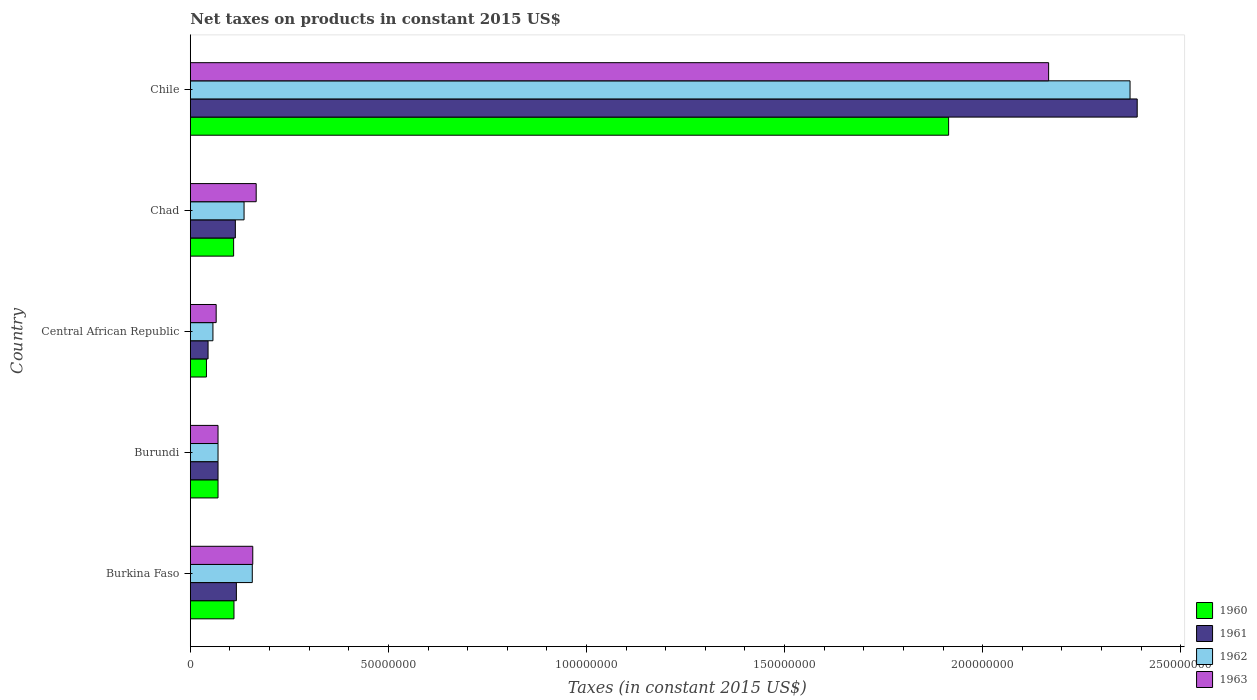How many groups of bars are there?
Offer a terse response. 5. Are the number of bars per tick equal to the number of legend labels?
Make the answer very short. Yes. How many bars are there on the 4th tick from the top?
Offer a terse response. 4. How many bars are there on the 3rd tick from the bottom?
Your answer should be compact. 4. In how many cases, is the number of bars for a given country not equal to the number of legend labels?
Provide a short and direct response. 0. What is the net taxes on products in 1963 in Chad?
Give a very brief answer. 1.66e+07. Across all countries, what is the maximum net taxes on products in 1962?
Your response must be concise. 2.37e+08. Across all countries, what is the minimum net taxes on products in 1960?
Provide a succinct answer. 4.08e+06. In which country was the net taxes on products in 1960 maximum?
Give a very brief answer. Chile. In which country was the net taxes on products in 1963 minimum?
Give a very brief answer. Central African Republic. What is the total net taxes on products in 1962 in the graph?
Make the answer very short. 2.79e+08. What is the difference between the net taxes on products in 1962 in Burundi and that in Central African Republic?
Your answer should be compact. 1.29e+06. What is the difference between the net taxes on products in 1963 in Burkina Faso and the net taxes on products in 1960 in Central African Republic?
Ensure brevity in your answer.  1.17e+07. What is the average net taxes on products in 1962 per country?
Provide a succinct answer. 5.58e+07. What is the ratio of the net taxes on products in 1961 in Central African Republic to that in Chad?
Your response must be concise. 0.39. Is the net taxes on products in 1960 in Chad less than that in Chile?
Keep it short and to the point. Yes. What is the difference between the highest and the second highest net taxes on products in 1963?
Offer a very short reply. 2.00e+08. What is the difference between the highest and the lowest net taxes on products in 1962?
Your answer should be very brief. 2.31e+08. In how many countries, is the net taxes on products in 1960 greater than the average net taxes on products in 1960 taken over all countries?
Your answer should be compact. 1. Is it the case that in every country, the sum of the net taxes on products in 1960 and net taxes on products in 1961 is greater than the sum of net taxes on products in 1962 and net taxes on products in 1963?
Your answer should be very brief. No. What does the 2nd bar from the top in Burkina Faso represents?
Make the answer very short. 1962. Are all the bars in the graph horizontal?
Keep it short and to the point. Yes. Does the graph contain any zero values?
Offer a very short reply. No. Where does the legend appear in the graph?
Give a very brief answer. Bottom right. What is the title of the graph?
Ensure brevity in your answer.  Net taxes on products in constant 2015 US$. Does "2015" appear as one of the legend labels in the graph?
Your answer should be compact. No. What is the label or title of the X-axis?
Make the answer very short. Taxes (in constant 2015 US$). What is the label or title of the Y-axis?
Offer a very short reply. Country. What is the Taxes (in constant 2015 US$) in 1960 in Burkina Faso?
Give a very brief answer. 1.10e+07. What is the Taxes (in constant 2015 US$) of 1961 in Burkina Faso?
Your response must be concise. 1.16e+07. What is the Taxes (in constant 2015 US$) in 1962 in Burkina Faso?
Offer a very short reply. 1.56e+07. What is the Taxes (in constant 2015 US$) in 1963 in Burkina Faso?
Your answer should be very brief. 1.58e+07. What is the Taxes (in constant 2015 US$) of 1963 in Burundi?
Offer a terse response. 7.00e+06. What is the Taxes (in constant 2015 US$) of 1960 in Central African Republic?
Give a very brief answer. 4.08e+06. What is the Taxes (in constant 2015 US$) of 1961 in Central African Republic?
Your response must be concise. 4.49e+06. What is the Taxes (in constant 2015 US$) of 1962 in Central African Republic?
Your answer should be very brief. 5.71e+06. What is the Taxes (in constant 2015 US$) in 1963 in Central African Republic?
Offer a very short reply. 6.53e+06. What is the Taxes (in constant 2015 US$) of 1960 in Chad?
Keep it short and to the point. 1.09e+07. What is the Taxes (in constant 2015 US$) in 1961 in Chad?
Give a very brief answer. 1.14e+07. What is the Taxes (in constant 2015 US$) of 1962 in Chad?
Offer a very short reply. 1.36e+07. What is the Taxes (in constant 2015 US$) of 1963 in Chad?
Offer a very short reply. 1.66e+07. What is the Taxes (in constant 2015 US$) of 1960 in Chile?
Give a very brief answer. 1.91e+08. What is the Taxes (in constant 2015 US$) in 1961 in Chile?
Provide a succinct answer. 2.39e+08. What is the Taxes (in constant 2015 US$) in 1962 in Chile?
Give a very brief answer. 2.37e+08. What is the Taxes (in constant 2015 US$) in 1963 in Chile?
Provide a short and direct response. 2.17e+08. Across all countries, what is the maximum Taxes (in constant 2015 US$) of 1960?
Your answer should be compact. 1.91e+08. Across all countries, what is the maximum Taxes (in constant 2015 US$) in 1961?
Ensure brevity in your answer.  2.39e+08. Across all countries, what is the maximum Taxes (in constant 2015 US$) in 1962?
Offer a terse response. 2.37e+08. Across all countries, what is the maximum Taxes (in constant 2015 US$) in 1963?
Offer a very short reply. 2.17e+08. Across all countries, what is the minimum Taxes (in constant 2015 US$) in 1960?
Your response must be concise. 4.08e+06. Across all countries, what is the minimum Taxes (in constant 2015 US$) in 1961?
Make the answer very short. 4.49e+06. Across all countries, what is the minimum Taxes (in constant 2015 US$) of 1962?
Offer a very short reply. 5.71e+06. Across all countries, what is the minimum Taxes (in constant 2015 US$) of 1963?
Offer a very short reply. 6.53e+06. What is the total Taxes (in constant 2015 US$) of 1960 in the graph?
Offer a very short reply. 2.24e+08. What is the total Taxes (in constant 2015 US$) in 1961 in the graph?
Offer a terse response. 2.73e+08. What is the total Taxes (in constant 2015 US$) of 1962 in the graph?
Give a very brief answer. 2.79e+08. What is the total Taxes (in constant 2015 US$) of 1963 in the graph?
Provide a short and direct response. 2.63e+08. What is the difference between the Taxes (in constant 2015 US$) in 1960 in Burkina Faso and that in Burundi?
Make the answer very short. 4.02e+06. What is the difference between the Taxes (in constant 2015 US$) in 1961 in Burkina Faso and that in Burundi?
Your answer should be compact. 4.63e+06. What is the difference between the Taxes (in constant 2015 US$) in 1962 in Burkina Faso and that in Burundi?
Your answer should be very brief. 8.65e+06. What is the difference between the Taxes (in constant 2015 US$) of 1963 in Burkina Faso and that in Burundi?
Your answer should be compact. 8.77e+06. What is the difference between the Taxes (in constant 2015 US$) of 1960 in Burkina Faso and that in Central African Republic?
Ensure brevity in your answer.  6.94e+06. What is the difference between the Taxes (in constant 2015 US$) of 1961 in Burkina Faso and that in Central African Republic?
Make the answer very short. 7.15e+06. What is the difference between the Taxes (in constant 2015 US$) in 1962 in Burkina Faso and that in Central African Republic?
Provide a short and direct response. 9.93e+06. What is the difference between the Taxes (in constant 2015 US$) of 1963 in Burkina Faso and that in Central African Republic?
Offer a very short reply. 9.24e+06. What is the difference between the Taxes (in constant 2015 US$) in 1960 in Burkina Faso and that in Chad?
Your answer should be very brief. 8.71e+04. What is the difference between the Taxes (in constant 2015 US$) in 1961 in Burkina Faso and that in Chad?
Give a very brief answer. 2.61e+05. What is the difference between the Taxes (in constant 2015 US$) in 1962 in Burkina Faso and that in Chad?
Your answer should be very brief. 2.08e+06. What is the difference between the Taxes (in constant 2015 US$) of 1963 in Burkina Faso and that in Chad?
Offer a very short reply. -8.65e+05. What is the difference between the Taxes (in constant 2015 US$) in 1960 in Burkina Faso and that in Chile?
Offer a very short reply. -1.80e+08. What is the difference between the Taxes (in constant 2015 US$) in 1961 in Burkina Faso and that in Chile?
Offer a terse response. -2.27e+08. What is the difference between the Taxes (in constant 2015 US$) of 1962 in Burkina Faso and that in Chile?
Ensure brevity in your answer.  -2.22e+08. What is the difference between the Taxes (in constant 2015 US$) of 1963 in Burkina Faso and that in Chile?
Your answer should be compact. -2.01e+08. What is the difference between the Taxes (in constant 2015 US$) in 1960 in Burundi and that in Central African Republic?
Offer a terse response. 2.92e+06. What is the difference between the Taxes (in constant 2015 US$) in 1961 in Burundi and that in Central African Republic?
Your answer should be very brief. 2.51e+06. What is the difference between the Taxes (in constant 2015 US$) in 1962 in Burundi and that in Central African Republic?
Offer a very short reply. 1.29e+06. What is the difference between the Taxes (in constant 2015 US$) in 1963 in Burundi and that in Central African Republic?
Your answer should be very brief. 4.70e+05. What is the difference between the Taxes (in constant 2015 US$) of 1960 in Burundi and that in Chad?
Your answer should be compact. -3.94e+06. What is the difference between the Taxes (in constant 2015 US$) in 1961 in Burundi and that in Chad?
Your answer should be compact. -4.37e+06. What is the difference between the Taxes (in constant 2015 US$) in 1962 in Burundi and that in Chad?
Your answer should be very brief. -6.57e+06. What is the difference between the Taxes (in constant 2015 US$) in 1963 in Burundi and that in Chad?
Offer a very short reply. -9.63e+06. What is the difference between the Taxes (in constant 2015 US$) in 1960 in Burundi and that in Chile?
Your answer should be compact. -1.84e+08. What is the difference between the Taxes (in constant 2015 US$) of 1961 in Burundi and that in Chile?
Provide a succinct answer. -2.32e+08. What is the difference between the Taxes (in constant 2015 US$) of 1962 in Burundi and that in Chile?
Give a very brief answer. -2.30e+08. What is the difference between the Taxes (in constant 2015 US$) of 1963 in Burundi and that in Chile?
Your response must be concise. -2.10e+08. What is the difference between the Taxes (in constant 2015 US$) of 1960 in Central African Republic and that in Chad?
Make the answer very short. -6.86e+06. What is the difference between the Taxes (in constant 2015 US$) of 1961 in Central African Republic and that in Chad?
Keep it short and to the point. -6.88e+06. What is the difference between the Taxes (in constant 2015 US$) of 1962 in Central African Republic and that in Chad?
Keep it short and to the point. -7.86e+06. What is the difference between the Taxes (in constant 2015 US$) of 1963 in Central African Republic and that in Chad?
Make the answer very short. -1.01e+07. What is the difference between the Taxes (in constant 2015 US$) of 1960 in Central African Republic and that in Chile?
Your response must be concise. -1.87e+08. What is the difference between the Taxes (in constant 2015 US$) in 1961 in Central African Republic and that in Chile?
Provide a short and direct response. -2.35e+08. What is the difference between the Taxes (in constant 2015 US$) in 1962 in Central African Republic and that in Chile?
Give a very brief answer. -2.31e+08. What is the difference between the Taxes (in constant 2015 US$) of 1963 in Central African Republic and that in Chile?
Offer a terse response. -2.10e+08. What is the difference between the Taxes (in constant 2015 US$) in 1960 in Chad and that in Chile?
Provide a short and direct response. -1.80e+08. What is the difference between the Taxes (in constant 2015 US$) of 1961 in Chad and that in Chile?
Your answer should be very brief. -2.28e+08. What is the difference between the Taxes (in constant 2015 US$) in 1962 in Chad and that in Chile?
Give a very brief answer. -2.24e+08. What is the difference between the Taxes (in constant 2015 US$) in 1963 in Chad and that in Chile?
Keep it short and to the point. -2.00e+08. What is the difference between the Taxes (in constant 2015 US$) of 1960 in Burkina Faso and the Taxes (in constant 2015 US$) of 1961 in Burundi?
Give a very brief answer. 4.02e+06. What is the difference between the Taxes (in constant 2015 US$) of 1960 in Burkina Faso and the Taxes (in constant 2015 US$) of 1962 in Burundi?
Your answer should be very brief. 4.02e+06. What is the difference between the Taxes (in constant 2015 US$) in 1960 in Burkina Faso and the Taxes (in constant 2015 US$) in 1963 in Burundi?
Your answer should be compact. 4.02e+06. What is the difference between the Taxes (in constant 2015 US$) of 1961 in Burkina Faso and the Taxes (in constant 2015 US$) of 1962 in Burundi?
Ensure brevity in your answer.  4.63e+06. What is the difference between the Taxes (in constant 2015 US$) of 1961 in Burkina Faso and the Taxes (in constant 2015 US$) of 1963 in Burundi?
Give a very brief answer. 4.63e+06. What is the difference between the Taxes (in constant 2015 US$) in 1962 in Burkina Faso and the Taxes (in constant 2015 US$) in 1963 in Burundi?
Keep it short and to the point. 8.65e+06. What is the difference between the Taxes (in constant 2015 US$) in 1960 in Burkina Faso and the Taxes (in constant 2015 US$) in 1961 in Central African Republic?
Make the answer very short. 6.54e+06. What is the difference between the Taxes (in constant 2015 US$) in 1960 in Burkina Faso and the Taxes (in constant 2015 US$) in 1962 in Central African Republic?
Keep it short and to the point. 5.31e+06. What is the difference between the Taxes (in constant 2015 US$) of 1960 in Burkina Faso and the Taxes (in constant 2015 US$) of 1963 in Central African Republic?
Give a very brief answer. 4.49e+06. What is the difference between the Taxes (in constant 2015 US$) of 1961 in Burkina Faso and the Taxes (in constant 2015 US$) of 1962 in Central African Republic?
Your answer should be compact. 5.92e+06. What is the difference between the Taxes (in constant 2015 US$) of 1961 in Burkina Faso and the Taxes (in constant 2015 US$) of 1963 in Central African Republic?
Your answer should be compact. 5.10e+06. What is the difference between the Taxes (in constant 2015 US$) of 1962 in Burkina Faso and the Taxes (in constant 2015 US$) of 1963 in Central African Republic?
Ensure brevity in your answer.  9.12e+06. What is the difference between the Taxes (in constant 2015 US$) in 1960 in Burkina Faso and the Taxes (in constant 2015 US$) in 1961 in Chad?
Keep it short and to the point. -3.47e+05. What is the difference between the Taxes (in constant 2015 US$) of 1960 in Burkina Faso and the Taxes (in constant 2015 US$) of 1962 in Chad?
Make the answer very short. -2.55e+06. What is the difference between the Taxes (in constant 2015 US$) in 1960 in Burkina Faso and the Taxes (in constant 2015 US$) in 1963 in Chad?
Your response must be concise. -5.61e+06. What is the difference between the Taxes (in constant 2015 US$) in 1961 in Burkina Faso and the Taxes (in constant 2015 US$) in 1962 in Chad?
Offer a terse response. -1.94e+06. What is the difference between the Taxes (in constant 2015 US$) in 1961 in Burkina Faso and the Taxes (in constant 2015 US$) in 1963 in Chad?
Offer a terse response. -5.00e+06. What is the difference between the Taxes (in constant 2015 US$) in 1962 in Burkina Faso and the Taxes (in constant 2015 US$) in 1963 in Chad?
Provide a succinct answer. -9.87e+05. What is the difference between the Taxes (in constant 2015 US$) of 1960 in Burkina Faso and the Taxes (in constant 2015 US$) of 1961 in Chile?
Offer a very short reply. -2.28e+08. What is the difference between the Taxes (in constant 2015 US$) in 1960 in Burkina Faso and the Taxes (in constant 2015 US$) in 1962 in Chile?
Offer a very short reply. -2.26e+08. What is the difference between the Taxes (in constant 2015 US$) in 1960 in Burkina Faso and the Taxes (in constant 2015 US$) in 1963 in Chile?
Provide a succinct answer. -2.06e+08. What is the difference between the Taxes (in constant 2015 US$) in 1961 in Burkina Faso and the Taxes (in constant 2015 US$) in 1962 in Chile?
Provide a succinct answer. -2.26e+08. What is the difference between the Taxes (in constant 2015 US$) in 1961 in Burkina Faso and the Taxes (in constant 2015 US$) in 1963 in Chile?
Provide a succinct answer. -2.05e+08. What is the difference between the Taxes (in constant 2015 US$) in 1962 in Burkina Faso and the Taxes (in constant 2015 US$) in 1963 in Chile?
Offer a terse response. -2.01e+08. What is the difference between the Taxes (in constant 2015 US$) in 1960 in Burundi and the Taxes (in constant 2015 US$) in 1961 in Central African Republic?
Offer a terse response. 2.51e+06. What is the difference between the Taxes (in constant 2015 US$) of 1960 in Burundi and the Taxes (in constant 2015 US$) of 1962 in Central African Republic?
Ensure brevity in your answer.  1.29e+06. What is the difference between the Taxes (in constant 2015 US$) of 1960 in Burundi and the Taxes (in constant 2015 US$) of 1963 in Central African Republic?
Your answer should be compact. 4.70e+05. What is the difference between the Taxes (in constant 2015 US$) of 1961 in Burundi and the Taxes (in constant 2015 US$) of 1962 in Central African Republic?
Ensure brevity in your answer.  1.29e+06. What is the difference between the Taxes (in constant 2015 US$) of 1961 in Burundi and the Taxes (in constant 2015 US$) of 1963 in Central African Republic?
Your answer should be compact. 4.70e+05. What is the difference between the Taxes (in constant 2015 US$) of 1962 in Burundi and the Taxes (in constant 2015 US$) of 1963 in Central African Republic?
Your response must be concise. 4.70e+05. What is the difference between the Taxes (in constant 2015 US$) of 1960 in Burundi and the Taxes (in constant 2015 US$) of 1961 in Chad?
Your answer should be very brief. -4.37e+06. What is the difference between the Taxes (in constant 2015 US$) in 1960 in Burundi and the Taxes (in constant 2015 US$) in 1962 in Chad?
Your answer should be very brief. -6.57e+06. What is the difference between the Taxes (in constant 2015 US$) in 1960 in Burundi and the Taxes (in constant 2015 US$) in 1963 in Chad?
Offer a very short reply. -9.63e+06. What is the difference between the Taxes (in constant 2015 US$) in 1961 in Burundi and the Taxes (in constant 2015 US$) in 1962 in Chad?
Your answer should be very brief. -6.57e+06. What is the difference between the Taxes (in constant 2015 US$) of 1961 in Burundi and the Taxes (in constant 2015 US$) of 1963 in Chad?
Your answer should be very brief. -9.63e+06. What is the difference between the Taxes (in constant 2015 US$) of 1962 in Burundi and the Taxes (in constant 2015 US$) of 1963 in Chad?
Offer a terse response. -9.63e+06. What is the difference between the Taxes (in constant 2015 US$) of 1960 in Burundi and the Taxes (in constant 2015 US$) of 1961 in Chile?
Keep it short and to the point. -2.32e+08. What is the difference between the Taxes (in constant 2015 US$) of 1960 in Burundi and the Taxes (in constant 2015 US$) of 1962 in Chile?
Your answer should be compact. -2.30e+08. What is the difference between the Taxes (in constant 2015 US$) of 1960 in Burundi and the Taxes (in constant 2015 US$) of 1963 in Chile?
Offer a terse response. -2.10e+08. What is the difference between the Taxes (in constant 2015 US$) of 1961 in Burundi and the Taxes (in constant 2015 US$) of 1962 in Chile?
Your response must be concise. -2.30e+08. What is the difference between the Taxes (in constant 2015 US$) of 1961 in Burundi and the Taxes (in constant 2015 US$) of 1963 in Chile?
Provide a short and direct response. -2.10e+08. What is the difference between the Taxes (in constant 2015 US$) in 1962 in Burundi and the Taxes (in constant 2015 US$) in 1963 in Chile?
Your answer should be very brief. -2.10e+08. What is the difference between the Taxes (in constant 2015 US$) in 1960 in Central African Republic and the Taxes (in constant 2015 US$) in 1961 in Chad?
Give a very brief answer. -7.29e+06. What is the difference between the Taxes (in constant 2015 US$) in 1960 in Central African Republic and the Taxes (in constant 2015 US$) in 1962 in Chad?
Give a very brief answer. -9.49e+06. What is the difference between the Taxes (in constant 2015 US$) of 1960 in Central African Republic and the Taxes (in constant 2015 US$) of 1963 in Chad?
Ensure brevity in your answer.  -1.26e+07. What is the difference between the Taxes (in constant 2015 US$) of 1961 in Central African Republic and the Taxes (in constant 2015 US$) of 1962 in Chad?
Your answer should be very brief. -9.08e+06. What is the difference between the Taxes (in constant 2015 US$) of 1961 in Central African Republic and the Taxes (in constant 2015 US$) of 1963 in Chad?
Ensure brevity in your answer.  -1.21e+07. What is the difference between the Taxes (in constant 2015 US$) in 1962 in Central African Republic and the Taxes (in constant 2015 US$) in 1963 in Chad?
Provide a succinct answer. -1.09e+07. What is the difference between the Taxes (in constant 2015 US$) of 1960 in Central African Republic and the Taxes (in constant 2015 US$) of 1961 in Chile?
Your response must be concise. -2.35e+08. What is the difference between the Taxes (in constant 2015 US$) of 1960 in Central African Republic and the Taxes (in constant 2015 US$) of 1962 in Chile?
Keep it short and to the point. -2.33e+08. What is the difference between the Taxes (in constant 2015 US$) of 1960 in Central African Republic and the Taxes (in constant 2015 US$) of 1963 in Chile?
Provide a short and direct response. -2.13e+08. What is the difference between the Taxes (in constant 2015 US$) in 1961 in Central African Republic and the Taxes (in constant 2015 US$) in 1962 in Chile?
Your answer should be very brief. -2.33e+08. What is the difference between the Taxes (in constant 2015 US$) in 1961 in Central African Republic and the Taxes (in constant 2015 US$) in 1963 in Chile?
Provide a short and direct response. -2.12e+08. What is the difference between the Taxes (in constant 2015 US$) in 1962 in Central African Republic and the Taxes (in constant 2015 US$) in 1963 in Chile?
Your answer should be compact. -2.11e+08. What is the difference between the Taxes (in constant 2015 US$) of 1960 in Chad and the Taxes (in constant 2015 US$) of 1961 in Chile?
Make the answer very short. -2.28e+08. What is the difference between the Taxes (in constant 2015 US$) in 1960 in Chad and the Taxes (in constant 2015 US$) in 1962 in Chile?
Give a very brief answer. -2.26e+08. What is the difference between the Taxes (in constant 2015 US$) in 1960 in Chad and the Taxes (in constant 2015 US$) in 1963 in Chile?
Keep it short and to the point. -2.06e+08. What is the difference between the Taxes (in constant 2015 US$) of 1961 in Chad and the Taxes (in constant 2015 US$) of 1962 in Chile?
Offer a terse response. -2.26e+08. What is the difference between the Taxes (in constant 2015 US$) of 1961 in Chad and the Taxes (in constant 2015 US$) of 1963 in Chile?
Keep it short and to the point. -2.05e+08. What is the difference between the Taxes (in constant 2015 US$) of 1962 in Chad and the Taxes (in constant 2015 US$) of 1963 in Chile?
Provide a short and direct response. -2.03e+08. What is the average Taxes (in constant 2015 US$) in 1960 per country?
Make the answer very short. 4.49e+07. What is the average Taxes (in constant 2015 US$) of 1961 per country?
Offer a very short reply. 5.47e+07. What is the average Taxes (in constant 2015 US$) of 1962 per country?
Give a very brief answer. 5.58e+07. What is the average Taxes (in constant 2015 US$) in 1963 per country?
Your response must be concise. 5.25e+07. What is the difference between the Taxes (in constant 2015 US$) in 1960 and Taxes (in constant 2015 US$) in 1961 in Burkina Faso?
Keep it short and to the point. -6.08e+05. What is the difference between the Taxes (in constant 2015 US$) in 1960 and Taxes (in constant 2015 US$) in 1962 in Burkina Faso?
Your response must be concise. -4.62e+06. What is the difference between the Taxes (in constant 2015 US$) of 1960 and Taxes (in constant 2015 US$) of 1963 in Burkina Faso?
Make the answer very short. -4.75e+06. What is the difference between the Taxes (in constant 2015 US$) of 1961 and Taxes (in constant 2015 US$) of 1962 in Burkina Faso?
Keep it short and to the point. -4.02e+06. What is the difference between the Taxes (in constant 2015 US$) in 1961 and Taxes (in constant 2015 US$) in 1963 in Burkina Faso?
Make the answer very short. -4.14e+06. What is the difference between the Taxes (in constant 2015 US$) of 1962 and Taxes (in constant 2015 US$) of 1963 in Burkina Faso?
Your answer should be very brief. -1.22e+05. What is the difference between the Taxes (in constant 2015 US$) of 1960 and Taxes (in constant 2015 US$) of 1962 in Burundi?
Offer a terse response. 0. What is the difference between the Taxes (in constant 2015 US$) in 1961 and Taxes (in constant 2015 US$) in 1963 in Burundi?
Offer a very short reply. 0. What is the difference between the Taxes (in constant 2015 US$) in 1960 and Taxes (in constant 2015 US$) in 1961 in Central African Republic?
Offer a very short reply. -4.07e+05. What is the difference between the Taxes (in constant 2015 US$) in 1960 and Taxes (in constant 2015 US$) in 1962 in Central African Republic?
Keep it short and to the point. -1.64e+06. What is the difference between the Taxes (in constant 2015 US$) in 1960 and Taxes (in constant 2015 US$) in 1963 in Central African Republic?
Your answer should be compact. -2.45e+06. What is the difference between the Taxes (in constant 2015 US$) in 1961 and Taxes (in constant 2015 US$) in 1962 in Central African Republic?
Your answer should be compact. -1.23e+06. What is the difference between the Taxes (in constant 2015 US$) in 1961 and Taxes (in constant 2015 US$) in 1963 in Central African Republic?
Give a very brief answer. -2.05e+06. What is the difference between the Taxes (in constant 2015 US$) in 1962 and Taxes (in constant 2015 US$) in 1963 in Central African Republic?
Your answer should be compact. -8.16e+05. What is the difference between the Taxes (in constant 2015 US$) of 1960 and Taxes (in constant 2015 US$) of 1961 in Chad?
Give a very brief answer. -4.34e+05. What is the difference between the Taxes (in constant 2015 US$) of 1960 and Taxes (in constant 2015 US$) of 1962 in Chad?
Offer a terse response. -2.63e+06. What is the difference between the Taxes (in constant 2015 US$) of 1960 and Taxes (in constant 2015 US$) of 1963 in Chad?
Keep it short and to the point. -5.70e+06. What is the difference between the Taxes (in constant 2015 US$) of 1961 and Taxes (in constant 2015 US$) of 1962 in Chad?
Your answer should be very brief. -2.20e+06. What is the difference between the Taxes (in constant 2015 US$) in 1961 and Taxes (in constant 2015 US$) in 1963 in Chad?
Your response must be concise. -5.26e+06. What is the difference between the Taxes (in constant 2015 US$) of 1962 and Taxes (in constant 2015 US$) of 1963 in Chad?
Offer a terse response. -3.06e+06. What is the difference between the Taxes (in constant 2015 US$) of 1960 and Taxes (in constant 2015 US$) of 1961 in Chile?
Offer a very short reply. -4.76e+07. What is the difference between the Taxes (in constant 2015 US$) of 1960 and Taxes (in constant 2015 US$) of 1962 in Chile?
Offer a very short reply. -4.58e+07. What is the difference between the Taxes (in constant 2015 US$) of 1960 and Taxes (in constant 2015 US$) of 1963 in Chile?
Make the answer very short. -2.52e+07. What is the difference between the Taxes (in constant 2015 US$) of 1961 and Taxes (in constant 2015 US$) of 1962 in Chile?
Your answer should be compact. 1.81e+06. What is the difference between the Taxes (in constant 2015 US$) of 1961 and Taxes (in constant 2015 US$) of 1963 in Chile?
Keep it short and to the point. 2.24e+07. What is the difference between the Taxes (in constant 2015 US$) in 1962 and Taxes (in constant 2015 US$) in 1963 in Chile?
Give a very brief answer. 2.06e+07. What is the ratio of the Taxes (in constant 2015 US$) in 1960 in Burkina Faso to that in Burundi?
Ensure brevity in your answer.  1.57. What is the ratio of the Taxes (in constant 2015 US$) in 1961 in Burkina Faso to that in Burundi?
Ensure brevity in your answer.  1.66. What is the ratio of the Taxes (in constant 2015 US$) in 1962 in Burkina Faso to that in Burundi?
Make the answer very short. 2.24. What is the ratio of the Taxes (in constant 2015 US$) in 1963 in Burkina Faso to that in Burundi?
Offer a very short reply. 2.25. What is the ratio of the Taxes (in constant 2015 US$) of 1960 in Burkina Faso to that in Central African Republic?
Your answer should be compact. 2.7. What is the ratio of the Taxes (in constant 2015 US$) of 1961 in Burkina Faso to that in Central African Republic?
Ensure brevity in your answer.  2.59. What is the ratio of the Taxes (in constant 2015 US$) of 1962 in Burkina Faso to that in Central African Republic?
Give a very brief answer. 2.74. What is the ratio of the Taxes (in constant 2015 US$) of 1963 in Burkina Faso to that in Central African Republic?
Your response must be concise. 2.41. What is the ratio of the Taxes (in constant 2015 US$) in 1961 in Burkina Faso to that in Chad?
Your response must be concise. 1.02. What is the ratio of the Taxes (in constant 2015 US$) of 1962 in Burkina Faso to that in Chad?
Ensure brevity in your answer.  1.15. What is the ratio of the Taxes (in constant 2015 US$) of 1963 in Burkina Faso to that in Chad?
Your answer should be very brief. 0.95. What is the ratio of the Taxes (in constant 2015 US$) of 1960 in Burkina Faso to that in Chile?
Ensure brevity in your answer.  0.06. What is the ratio of the Taxes (in constant 2015 US$) of 1961 in Burkina Faso to that in Chile?
Keep it short and to the point. 0.05. What is the ratio of the Taxes (in constant 2015 US$) in 1962 in Burkina Faso to that in Chile?
Your response must be concise. 0.07. What is the ratio of the Taxes (in constant 2015 US$) in 1963 in Burkina Faso to that in Chile?
Provide a succinct answer. 0.07. What is the ratio of the Taxes (in constant 2015 US$) of 1960 in Burundi to that in Central African Republic?
Keep it short and to the point. 1.72. What is the ratio of the Taxes (in constant 2015 US$) in 1961 in Burundi to that in Central African Republic?
Give a very brief answer. 1.56. What is the ratio of the Taxes (in constant 2015 US$) of 1962 in Burundi to that in Central African Republic?
Your answer should be compact. 1.23. What is the ratio of the Taxes (in constant 2015 US$) of 1963 in Burundi to that in Central African Republic?
Your response must be concise. 1.07. What is the ratio of the Taxes (in constant 2015 US$) of 1960 in Burundi to that in Chad?
Offer a terse response. 0.64. What is the ratio of the Taxes (in constant 2015 US$) in 1961 in Burundi to that in Chad?
Your response must be concise. 0.62. What is the ratio of the Taxes (in constant 2015 US$) in 1962 in Burundi to that in Chad?
Offer a terse response. 0.52. What is the ratio of the Taxes (in constant 2015 US$) of 1963 in Burundi to that in Chad?
Provide a succinct answer. 0.42. What is the ratio of the Taxes (in constant 2015 US$) in 1960 in Burundi to that in Chile?
Keep it short and to the point. 0.04. What is the ratio of the Taxes (in constant 2015 US$) in 1961 in Burundi to that in Chile?
Your answer should be very brief. 0.03. What is the ratio of the Taxes (in constant 2015 US$) in 1962 in Burundi to that in Chile?
Provide a succinct answer. 0.03. What is the ratio of the Taxes (in constant 2015 US$) of 1963 in Burundi to that in Chile?
Ensure brevity in your answer.  0.03. What is the ratio of the Taxes (in constant 2015 US$) in 1960 in Central African Republic to that in Chad?
Give a very brief answer. 0.37. What is the ratio of the Taxes (in constant 2015 US$) of 1961 in Central African Republic to that in Chad?
Offer a very short reply. 0.39. What is the ratio of the Taxes (in constant 2015 US$) in 1962 in Central African Republic to that in Chad?
Ensure brevity in your answer.  0.42. What is the ratio of the Taxes (in constant 2015 US$) in 1963 in Central African Republic to that in Chad?
Keep it short and to the point. 0.39. What is the ratio of the Taxes (in constant 2015 US$) of 1960 in Central African Republic to that in Chile?
Offer a very short reply. 0.02. What is the ratio of the Taxes (in constant 2015 US$) of 1961 in Central African Republic to that in Chile?
Make the answer very short. 0.02. What is the ratio of the Taxes (in constant 2015 US$) in 1962 in Central African Republic to that in Chile?
Your answer should be very brief. 0.02. What is the ratio of the Taxes (in constant 2015 US$) in 1963 in Central African Republic to that in Chile?
Offer a very short reply. 0.03. What is the ratio of the Taxes (in constant 2015 US$) in 1960 in Chad to that in Chile?
Your answer should be compact. 0.06. What is the ratio of the Taxes (in constant 2015 US$) in 1961 in Chad to that in Chile?
Offer a terse response. 0.05. What is the ratio of the Taxes (in constant 2015 US$) of 1962 in Chad to that in Chile?
Ensure brevity in your answer.  0.06. What is the ratio of the Taxes (in constant 2015 US$) in 1963 in Chad to that in Chile?
Offer a terse response. 0.08. What is the difference between the highest and the second highest Taxes (in constant 2015 US$) in 1960?
Make the answer very short. 1.80e+08. What is the difference between the highest and the second highest Taxes (in constant 2015 US$) in 1961?
Provide a short and direct response. 2.27e+08. What is the difference between the highest and the second highest Taxes (in constant 2015 US$) of 1962?
Your answer should be very brief. 2.22e+08. What is the difference between the highest and the second highest Taxes (in constant 2015 US$) in 1963?
Offer a very short reply. 2.00e+08. What is the difference between the highest and the lowest Taxes (in constant 2015 US$) of 1960?
Keep it short and to the point. 1.87e+08. What is the difference between the highest and the lowest Taxes (in constant 2015 US$) of 1961?
Give a very brief answer. 2.35e+08. What is the difference between the highest and the lowest Taxes (in constant 2015 US$) in 1962?
Your response must be concise. 2.31e+08. What is the difference between the highest and the lowest Taxes (in constant 2015 US$) in 1963?
Your answer should be very brief. 2.10e+08. 